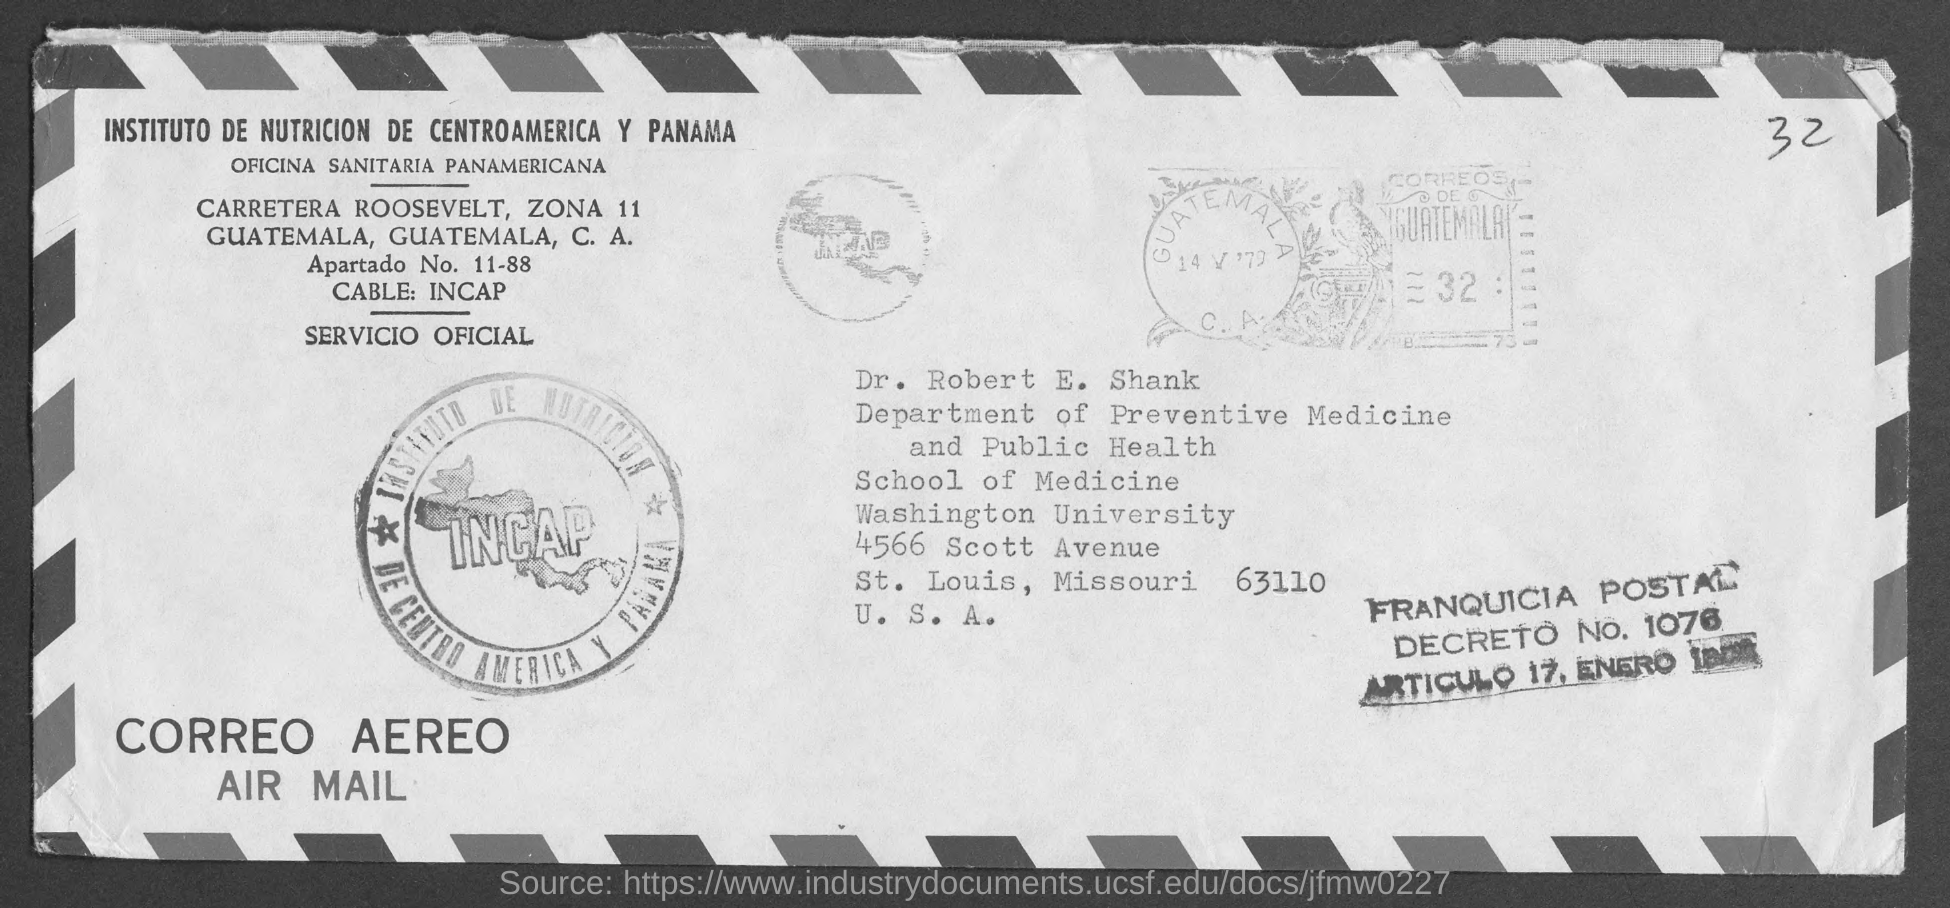To whom this post is sent ?
Provide a succinct answer. Dr. Robert E Shank. To which department dr. robert e shank belong to ?
Keep it short and to the point. Department of Preventive Medicine and public health. To which university dr. robert e shank belongs to ?
Offer a very short reply. Washington University. In which state and city Washington University  is located
Your response must be concise. St. louis , missouri. In which country Washington university is located ?
Provide a short and direct response. U.S.A. 